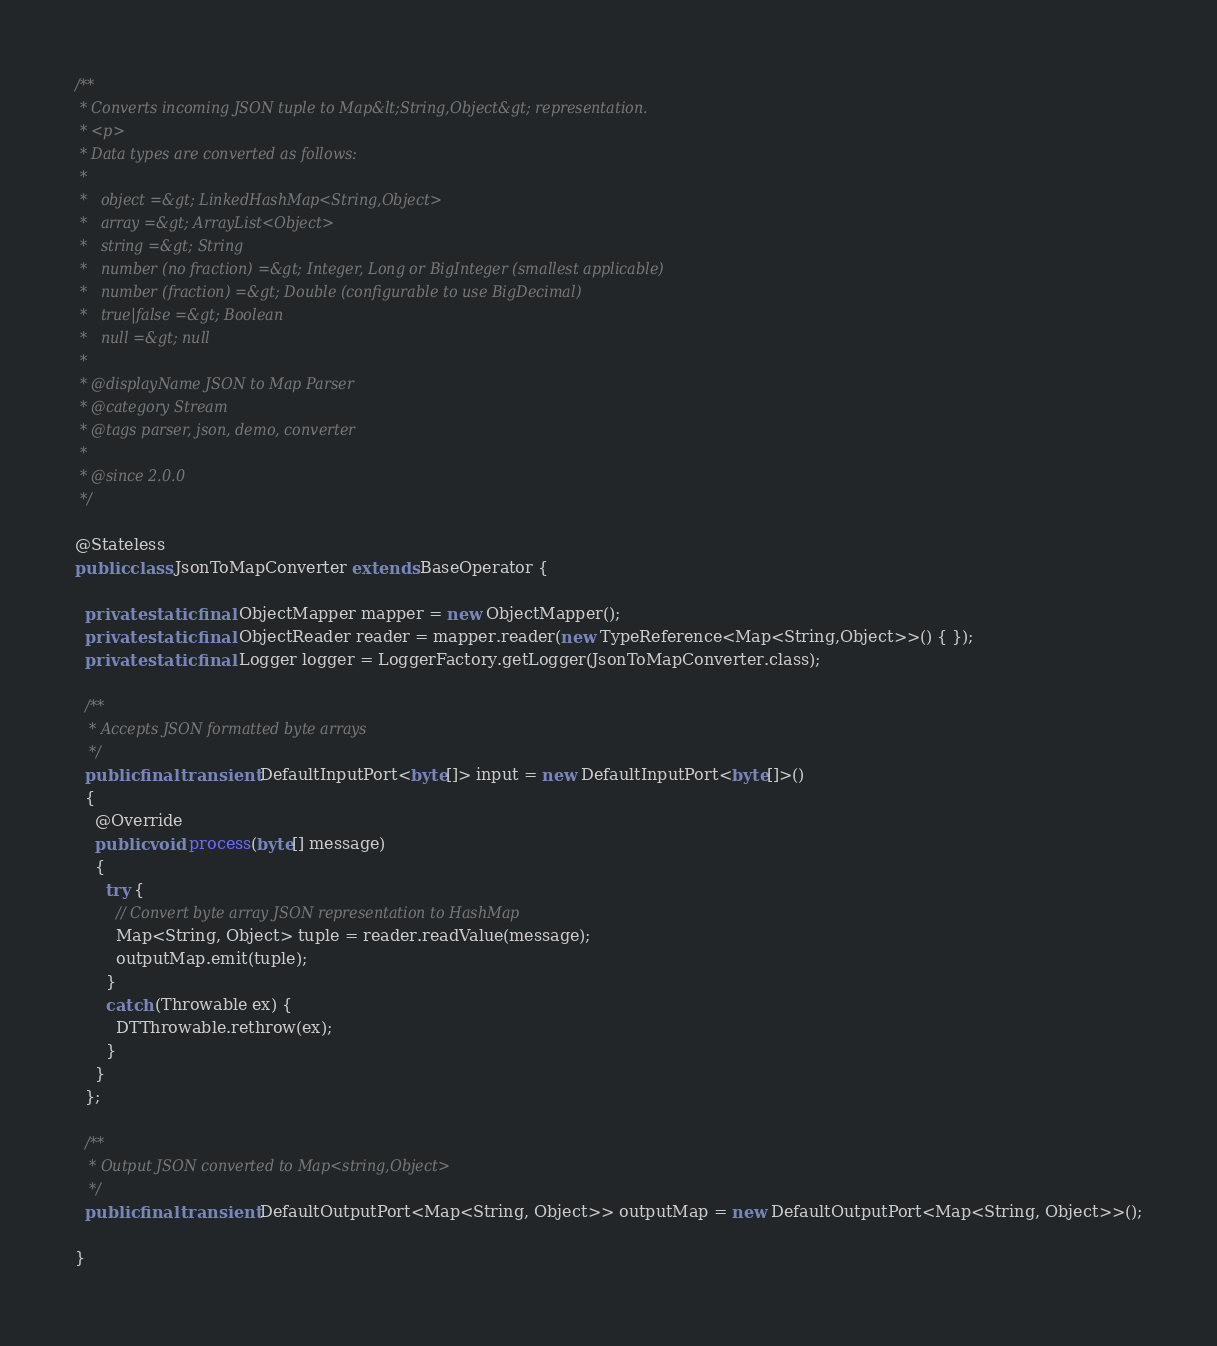<code> <loc_0><loc_0><loc_500><loc_500><_Java_>

/**
 * Converts incoming JSON tuple to Map&lt;String,Object&gt; representation.
 * <p>
 * Data types are converted as follows:
 *
 *   object =&gt; LinkedHashMap<String,Object>
 *   array =&gt; ArrayList<Object>
 *   string =&gt; String
 *   number (no fraction) =&gt; Integer, Long or BigInteger (smallest applicable)
 *   number (fraction) =&gt; Double (configurable to use BigDecimal)
 *   true|false =&gt; Boolean
 *   null =&gt; null
 *
 * @displayName JSON to Map Parser
 * @category Stream
 * @tags parser, json, demo, converter
 *
 * @since 2.0.0
 */

@Stateless
public class JsonToMapConverter extends BaseOperator {

  private static final ObjectMapper mapper = new ObjectMapper();
  private static final ObjectReader reader = mapper.reader(new TypeReference<Map<String,Object>>() { });
  private static final Logger logger = LoggerFactory.getLogger(JsonToMapConverter.class);

  /**
   * Accepts JSON formatted byte arrays
   */
  public final transient DefaultInputPort<byte[]> input = new DefaultInputPort<byte[]>()
  {
    @Override
    public void process(byte[] message)
    {
      try {
        // Convert byte array JSON representation to HashMap
        Map<String, Object> tuple = reader.readValue(message);
        outputMap.emit(tuple);
      }
      catch (Throwable ex) {
        DTThrowable.rethrow(ex);
      }
    }
  };

  /**
   * Output JSON converted to Map<string,Object>
   */
  public final transient DefaultOutputPort<Map<String, Object>> outputMap = new DefaultOutputPort<Map<String, Object>>();

}
</code> 